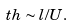Convert formula to latex. <formula><loc_0><loc_0><loc_500><loc_500>\ t h \sim l / U .</formula> 